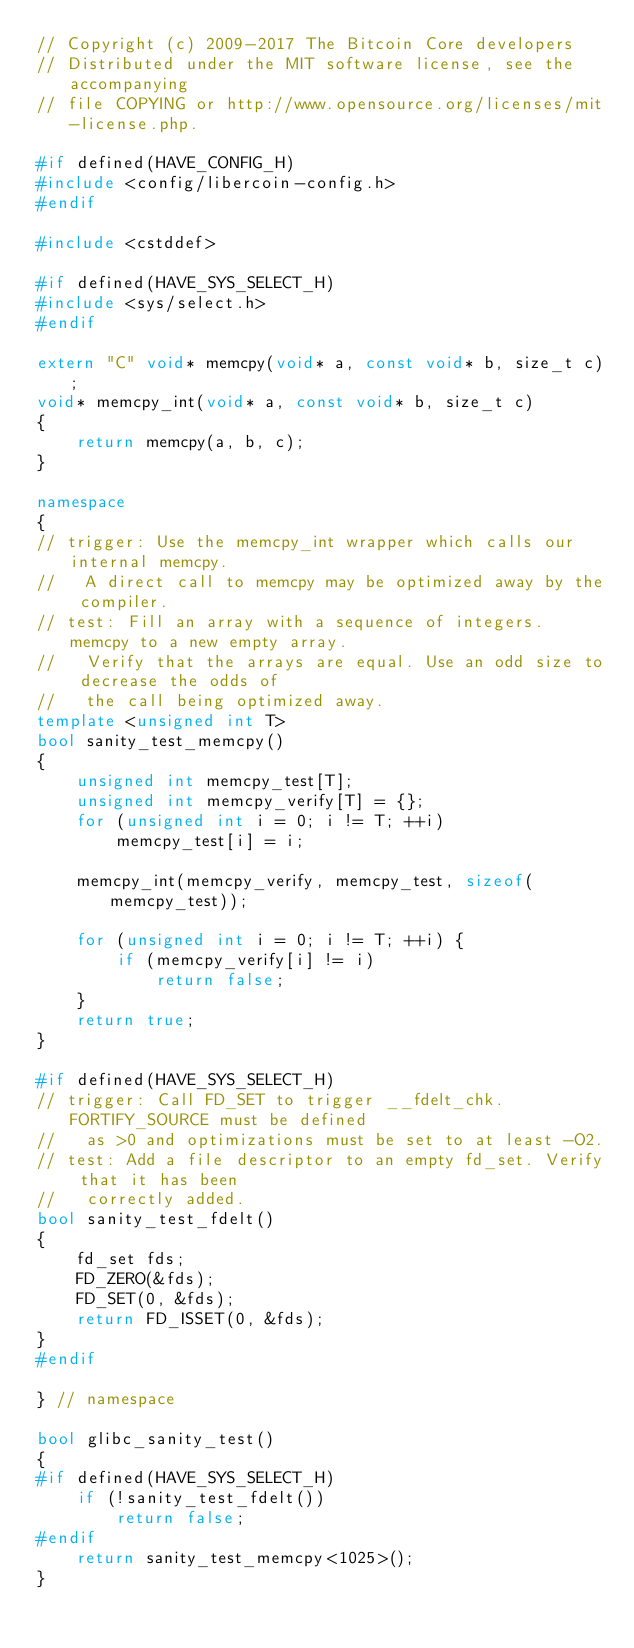<code> <loc_0><loc_0><loc_500><loc_500><_C++_>// Copyright (c) 2009-2017 The Bitcoin Core developers
// Distributed under the MIT software license, see the accompanying
// file COPYING or http://www.opensource.org/licenses/mit-license.php.

#if defined(HAVE_CONFIG_H)
#include <config/libercoin-config.h>
#endif

#include <cstddef>

#if defined(HAVE_SYS_SELECT_H)
#include <sys/select.h>
#endif

extern "C" void* memcpy(void* a, const void* b, size_t c);
void* memcpy_int(void* a, const void* b, size_t c)
{
    return memcpy(a, b, c);
}

namespace
{
// trigger: Use the memcpy_int wrapper which calls our internal memcpy.
//   A direct call to memcpy may be optimized away by the compiler.
// test: Fill an array with a sequence of integers. memcpy to a new empty array.
//   Verify that the arrays are equal. Use an odd size to decrease the odds of
//   the call being optimized away.
template <unsigned int T>
bool sanity_test_memcpy()
{
    unsigned int memcpy_test[T];
    unsigned int memcpy_verify[T] = {};
    for (unsigned int i = 0; i != T; ++i)
        memcpy_test[i] = i;

    memcpy_int(memcpy_verify, memcpy_test, sizeof(memcpy_test));

    for (unsigned int i = 0; i != T; ++i) {
        if (memcpy_verify[i] != i)
            return false;
    }
    return true;
}

#if defined(HAVE_SYS_SELECT_H)
// trigger: Call FD_SET to trigger __fdelt_chk. FORTIFY_SOURCE must be defined
//   as >0 and optimizations must be set to at least -O2.
// test: Add a file descriptor to an empty fd_set. Verify that it has been
//   correctly added.
bool sanity_test_fdelt()
{
    fd_set fds;
    FD_ZERO(&fds);
    FD_SET(0, &fds);
    return FD_ISSET(0, &fds);
}
#endif

} // namespace

bool glibc_sanity_test()
{
#if defined(HAVE_SYS_SELECT_H)
    if (!sanity_test_fdelt())
        return false;
#endif
    return sanity_test_memcpy<1025>();
}
</code> 